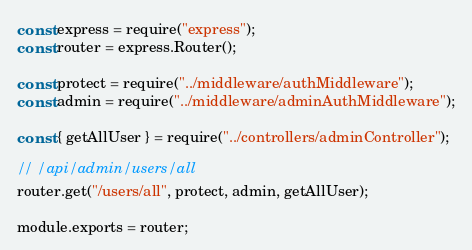Convert code to text. <code><loc_0><loc_0><loc_500><loc_500><_JavaScript_>const express = require("express");
const router = express.Router();

const protect = require("../middleware/authMiddleware");
const admin = require("../middleware/adminAuthMiddleware");

const { getAllUser } = require("../controllers/adminController");

// /api/admin/users/all
router.get("/users/all", protect, admin, getAllUser);

module.exports = router;
</code> 